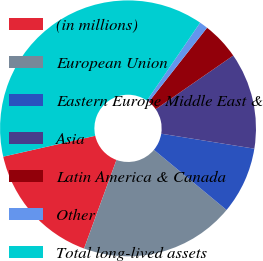<chart> <loc_0><loc_0><loc_500><loc_500><pie_chart><fcel>(in millions)<fcel>European Union<fcel>Eastern Europe Middle East &<fcel>Asia<fcel>Latin America & Canada<fcel>Other<fcel>Total long-lived assets<nl><fcel>15.87%<fcel>19.57%<fcel>8.47%<fcel>12.17%<fcel>4.77%<fcel>1.07%<fcel>38.07%<nl></chart> 